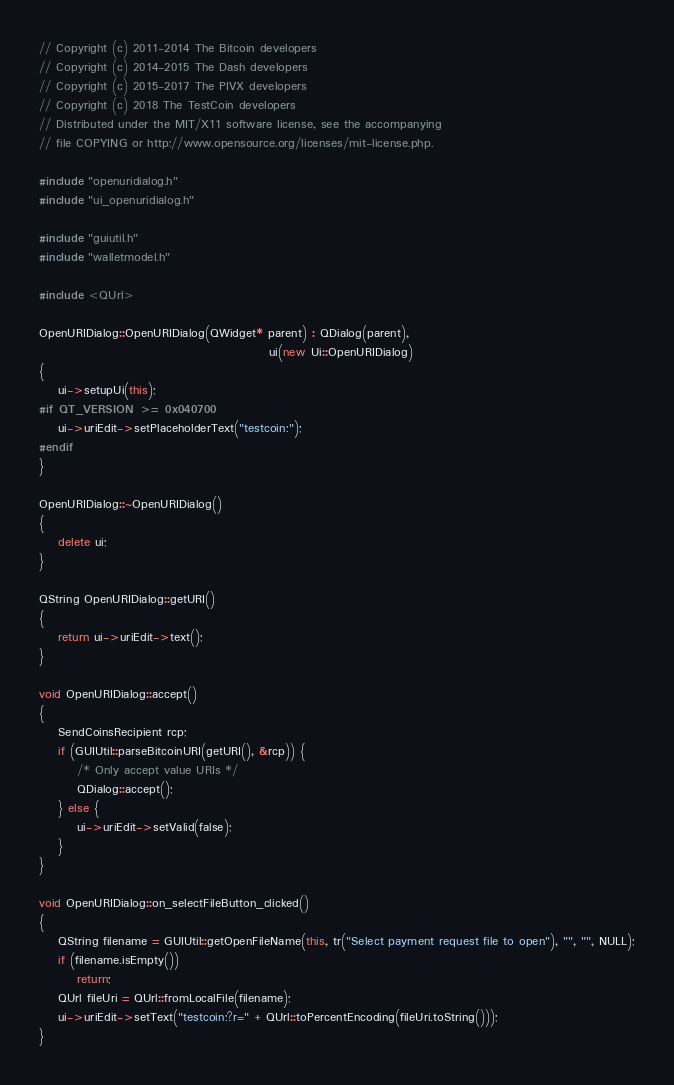<code> <loc_0><loc_0><loc_500><loc_500><_C++_>// Copyright (c) 2011-2014 The Bitcoin developers
// Copyright (c) 2014-2015 The Dash developers
// Copyright (c) 2015-2017 The PIVX developers
// Copyright (c) 2018 The TestCoin developers
// Distributed under the MIT/X11 software license, see the accompanying
// file COPYING or http://www.opensource.org/licenses/mit-license.php.

#include "openuridialog.h"
#include "ui_openuridialog.h"

#include "guiutil.h"
#include "walletmodel.h"

#include <QUrl>

OpenURIDialog::OpenURIDialog(QWidget* parent) : QDialog(parent),
                                                ui(new Ui::OpenURIDialog)
{
    ui->setupUi(this);
#if QT_VERSION >= 0x040700
    ui->uriEdit->setPlaceholderText("testcoin:");
#endif
}

OpenURIDialog::~OpenURIDialog()
{
    delete ui;
}

QString OpenURIDialog::getURI()
{
    return ui->uriEdit->text();
}

void OpenURIDialog::accept()
{
    SendCoinsRecipient rcp;
    if (GUIUtil::parseBitcoinURI(getURI(), &rcp)) {
        /* Only accept value URIs */
        QDialog::accept();
    } else {
        ui->uriEdit->setValid(false);
    }
}

void OpenURIDialog::on_selectFileButton_clicked()
{
    QString filename = GUIUtil::getOpenFileName(this, tr("Select payment request file to open"), "", "", NULL);
    if (filename.isEmpty())
        return;
    QUrl fileUri = QUrl::fromLocalFile(filename);
    ui->uriEdit->setText("testcoin:?r=" + QUrl::toPercentEncoding(fileUri.toString()));
}
</code> 